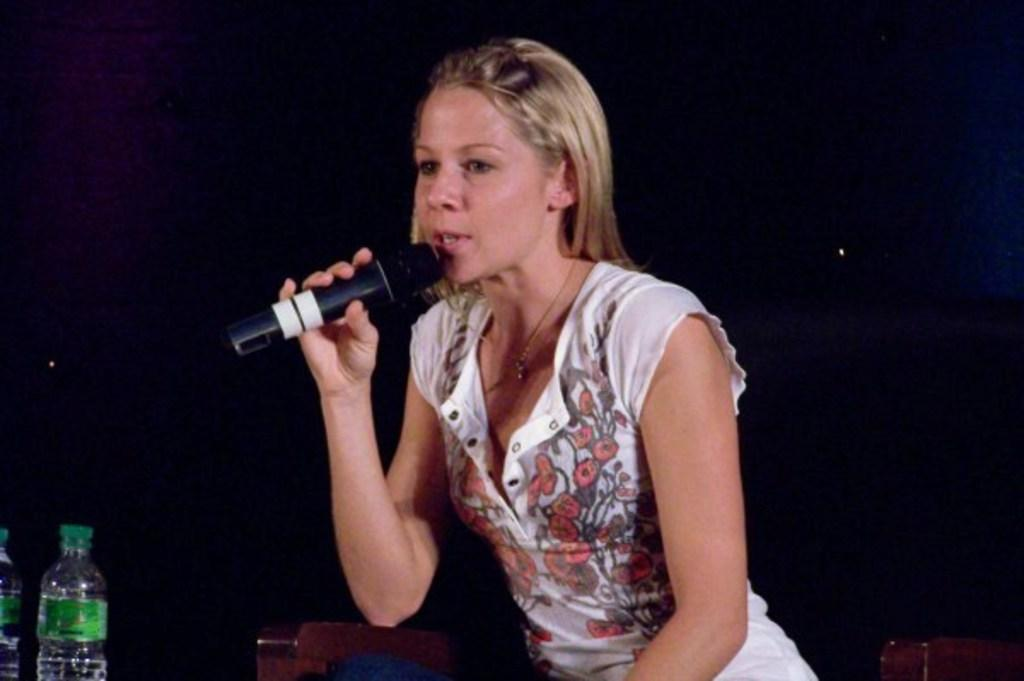Who is the main subject in the image? There is a woman in the image. What is the woman doing in the image? The woman is sitting and talking. What object is the woman holding in the image? The woman is holding a microphone. Are there any other objects visible in the image? Yes, there are two bottles in the bottom left side of the image. What type of curtain is hanging behind the woman in the image? There is no curtain visible in the image. What color is the dress the woman is wearing in the image? The provided facts do not mention the color or presence of a dress. 